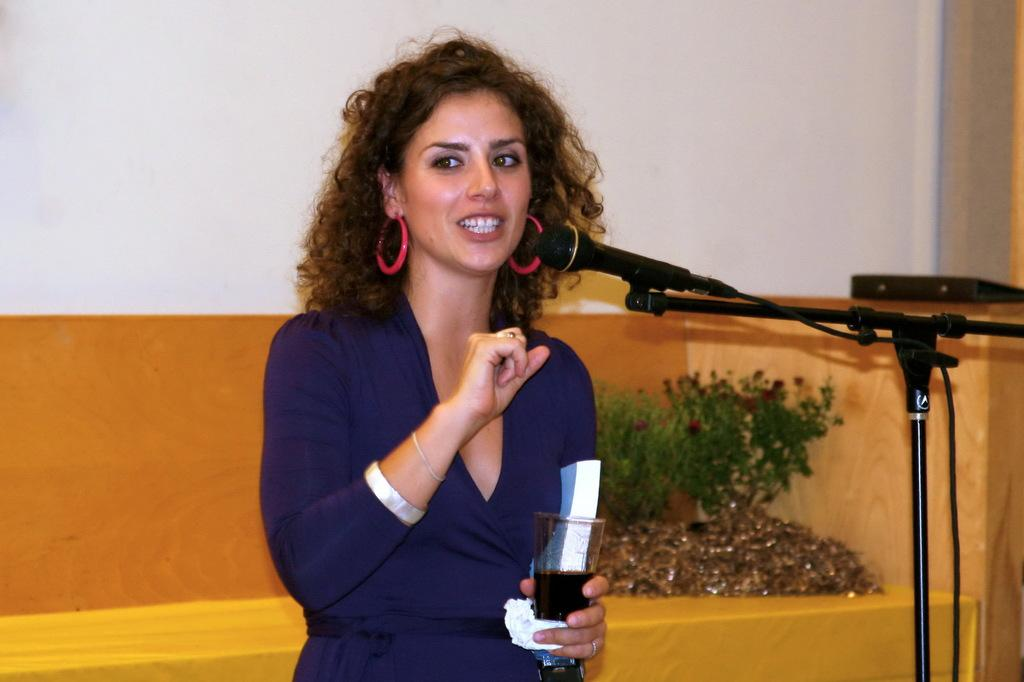What is the main subject of the image? There is a person in the image. What is the person wearing? The person is wearing a blue dress. What is the person holding in the image? The person is holding a glass. What can be seen near the person? There is a mic and a stand in the image. What is visible in the background of the image? Planets are visible in the background. What colors are present on the wall in the image? The wall has a white and orange color. How many clocks are hanging on the wall in the image? There are no clocks visible in the image; the wall has a white and orange color. What type of car is parked next to the person in the image? There is no car present in the image; it features a person, a blue dress, a glass, a mic, a stand, planets in the background, and a wall with a white and orange color. 